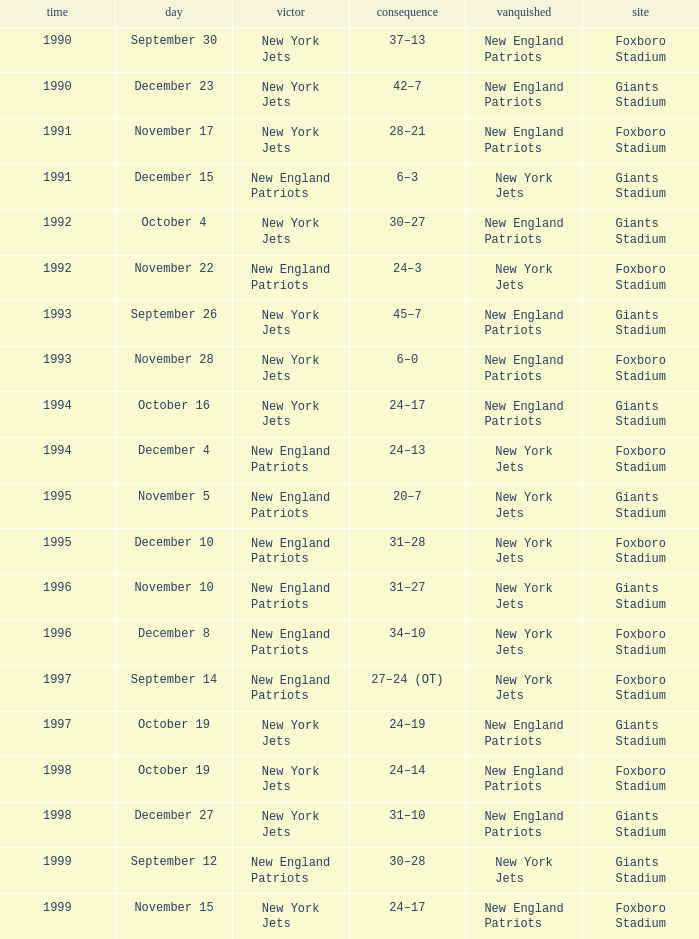What is the location when the new york jets lost earlier than 1997 and a Result of 31–28? Foxboro Stadium. 